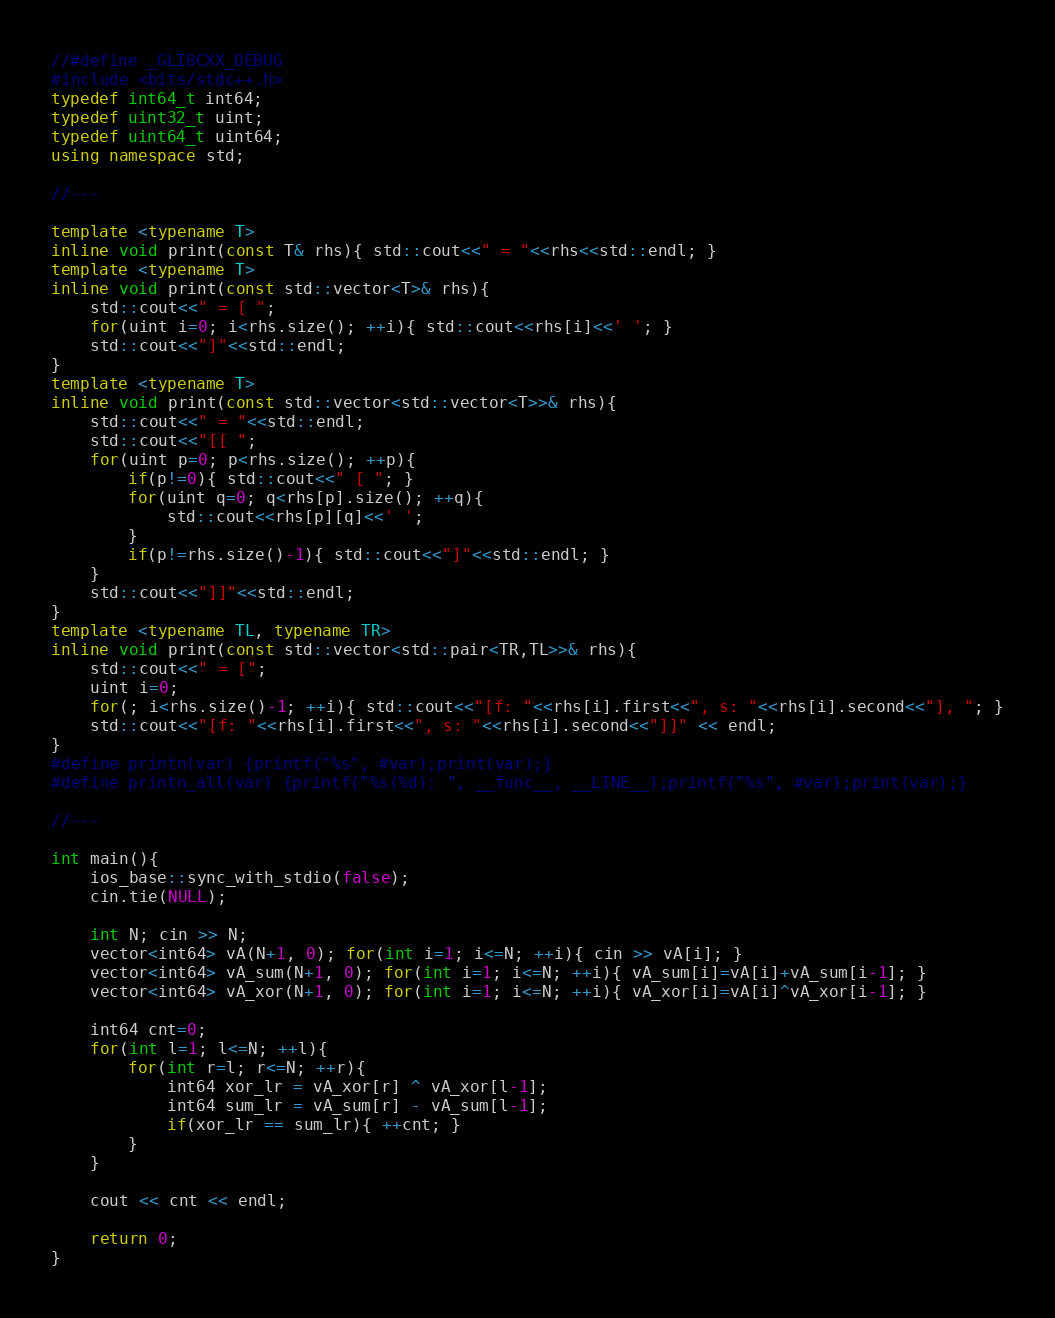<code> <loc_0><loc_0><loc_500><loc_500><_C++_>//#define _GLIBCXX_DEBUG
#include <bits/stdc++.h>
typedef int64_t int64;
typedef uint32_t uint;
typedef uint64_t uint64;
using namespace std;

//---

template <typename T>
inline void print(const T& rhs){ std::cout<<" = "<<rhs<<std::endl; }
template <typename T>
inline void print(const std::vector<T>& rhs){
    std::cout<<" = [ ";
    for(uint i=0; i<rhs.size(); ++i){ std::cout<<rhs[i]<<' '; }
    std::cout<<"]"<<std::endl;
}
template <typename T>
inline void print(const std::vector<std::vector<T>>& rhs){
    std::cout<<" = "<<std::endl;
    std::cout<<"[[ ";
    for(uint p=0; p<rhs.size(); ++p){
        if(p!=0){ std::cout<<" [ "; }
        for(uint q=0; q<rhs[p].size(); ++q){
            std::cout<<rhs[p][q]<<' ';
        }
        if(p!=rhs.size()-1){ std::cout<<"]"<<std::endl; }
    }
    std::cout<<"]]"<<std::endl;
}
template <typename TL, typename TR>
inline void print(const std::vector<std::pair<TR,TL>>& rhs){
    std::cout<<" = [";
    uint i=0;
    for(; i<rhs.size()-1; ++i){ std::cout<<"[f: "<<rhs[i].first<<", s: "<<rhs[i].second<<"], "; }
    std::cout<<"[f: "<<rhs[i].first<<", s: "<<rhs[i].second<<"]]" << endl;
}
#define printn(var) {printf("%s", #var);print(var);}
#define printn_all(var) {printf("%s(%d): ", __func__, __LINE__);printf("%s", #var);print(var);}

//---

int main(){
    ios_base::sync_with_stdio(false);
    cin.tie(NULL);
    
    int N; cin >> N;
    vector<int64> vA(N+1, 0); for(int i=1; i<=N; ++i){ cin >> vA[i]; }
    vector<int64> vA_sum(N+1, 0); for(int i=1; i<=N; ++i){ vA_sum[i]=vA[i]+vA_sum[i-1]; }
    vector<int64> vA_xor(N+1, 0); for(int i=1; i<=N; ++i){ vA_xor[i]=vA[i]^vA_xor[i-1]; }

    int64 cnt=0;
    for(int l=1; l<=N; ++l){
        for(int r=l; r<=N; ++r){
            int64 xor_lr = vA_xor[r] ^ vA_xor[l-1];
            int64 sum_lr = vA_sum[r] - vA_sum[l-1];
            if(xor_lr == sum_lr){ ++cnt; }
        }
    }
    
    cout << cnt << endl;
    
    return 0;
}</code> 